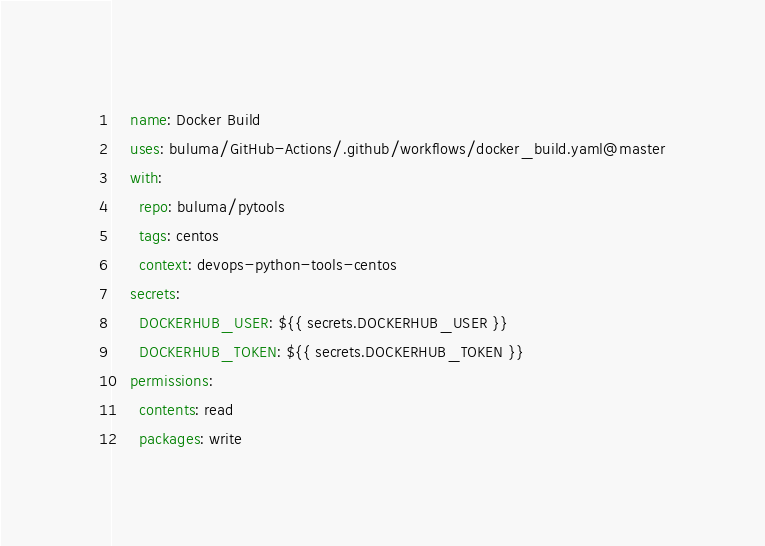Convert code to text. <code><loc_0><loc_0><loc_500><loc_500><_YAML_>    name: Docker Build
    uses: buluma/GitHub-Actions/.github/workflows/docker_build.yaml@master
    with:
      repo: buluma/pytools
      tags: centos
      context: devops-python-tools-centos
    secrets:
      DOCKERHUB_USER: ${{ secrets.DOCKERHUB_USER }}
      DOCKERHUB_TOKEN: ${{ secrets.DOCKERHUB_TOKEN }}
    permissions:
      contents: read
      packages: write
</code> 